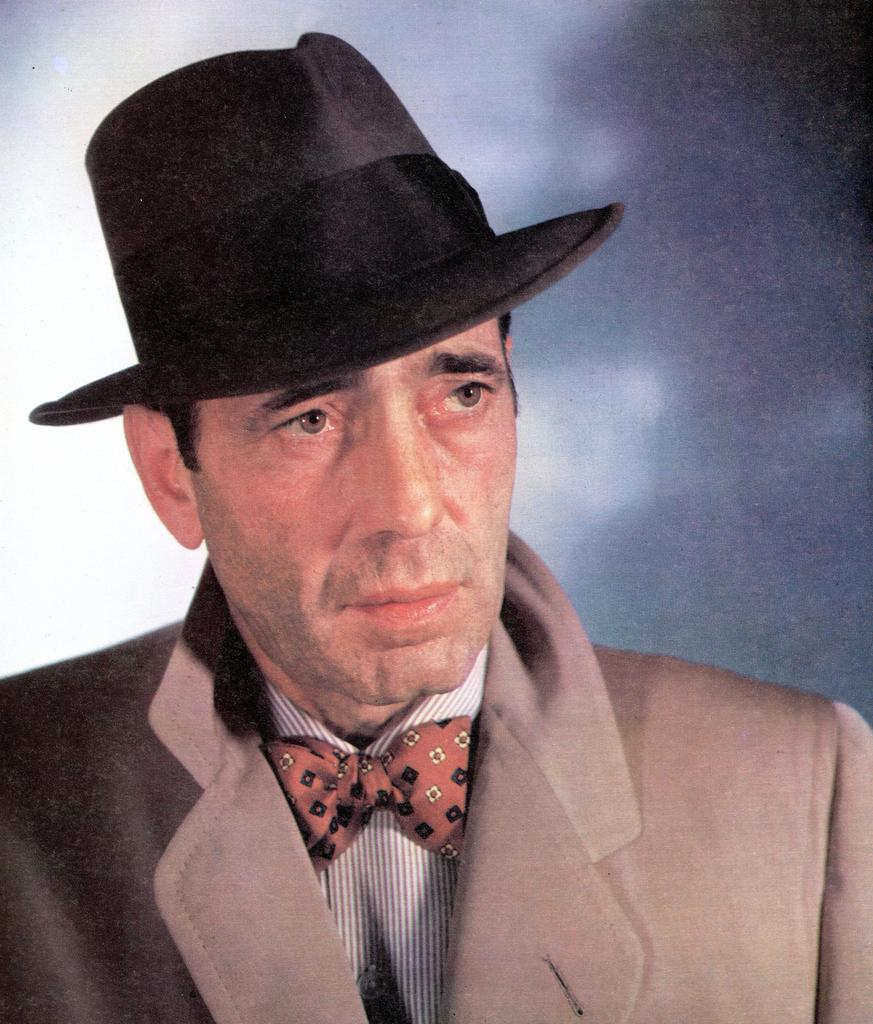What is the main subject in the foreground of the image? There is a man in the foreground of the image. What is the man wearing? The man is wearing a suit and a hat. What can be seen in the background of the image? In the background, there is a partial white and black area. What type of pipe is the man smoking in the image? There is no pipe visible in the image, and the man is not smoking. How much blood can be seen on the man's clothing in the image? There is no blood visible on the man's clothing in the image. 